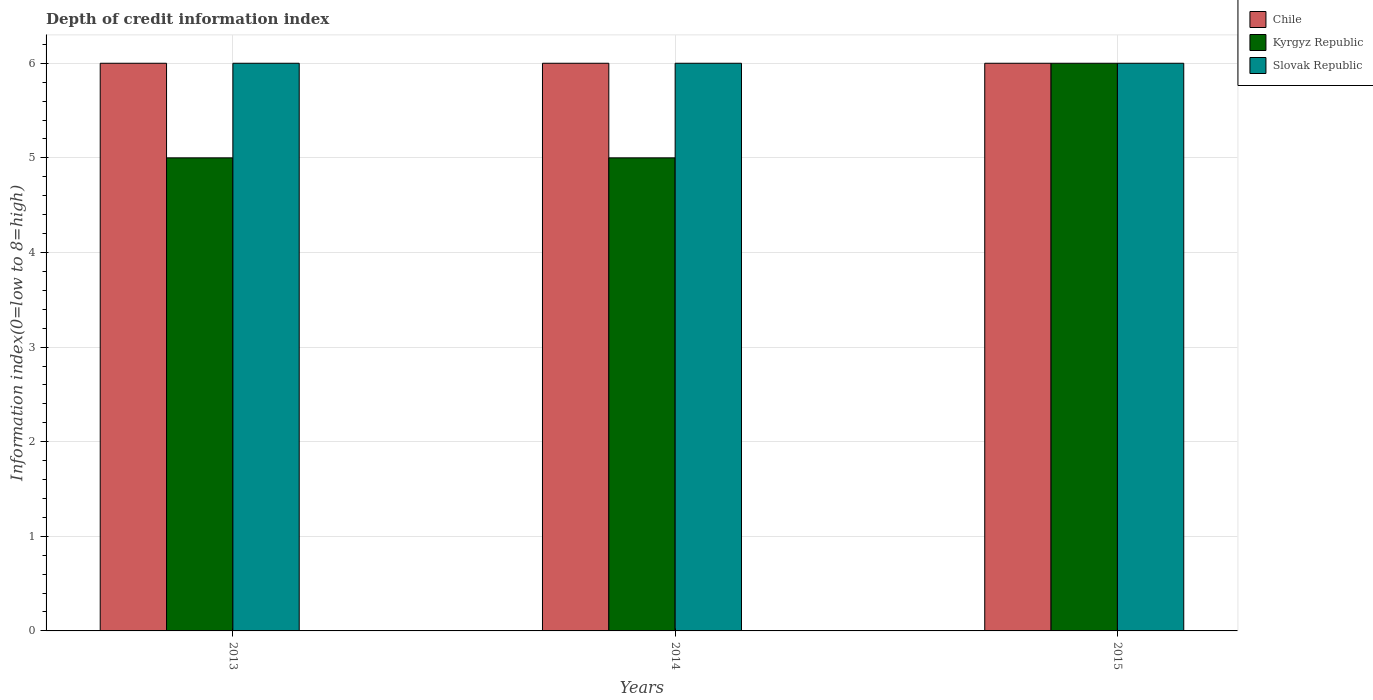How many different coloured bars are there?
Offer a terse response. 3. How many groups of bars are there?
Keep it short and to the point. 3. Are the number of bars per tick equal to the number of legend labels?
Make the answer very short. Yes. Are the number of bars on each tick of the X-axis equal?
Your response must be concise. Yes. How many bars are there on the 1st tick from the left?
Provide a succinct answer. 3. In how many cases, is the number of bars for a given year not equal to the number of legend labels?
Your answer should be very brief. 0. Across all years, what is the maximum information index in Kyrgyz Republic?
Your response must be concise. 6. Across all years, what is the minimum information index in Kyrgyz Republic?
Keep it short and to the point. 5. In which year was the information index in Kyrgyz Republic maximum?
Keep it short and to the point. 2015. What is the total information index in Slovak Republic in the graph?
Your answer should be very brief. 18. What is the difference between the information index in Kyrgyz Republic in 2015 and the information index in Slovak Republic in 2013?
Offer a very short reply. 0. In the year 2013, what is the difference between the information index in Slovak Republic and information index in Chile?
Provide a short and direct response. 0. In how many years, is the information index in Slovak Republic greater than 1.8?
Keep it short and to the point. 3. What is the ratio of the information index in Kyrgyz Republic in 2013 to that in 2014?
Give a very brief answer. 1. In how many years, is the information index in Chile greater than the average information index in Chile taken over all years?
Make the answer very short. 0. What does the 3rd bar from the left in 2015 represents?
Give a very brief answer. Slovak Republic. What does the 1st bar from the right in 2013 represents?
Provide a succinct answer. Slovak Republic. How many bars are there?
Provide a short and direct response. 9. Are all the bars in the graph horizontal?
Provide a short and direct response. No. Does the graph contain any zero values?
Your response must be concise. No. Where does the legend appear in the graph?
Keep it short and to the point. Top right. How many legend labels are there?
Your response must be concise. 3. What is the title of the graph?
Keep it short and to the point. Depth of credit information index. Does "Kazakhstan" appear as one of the legend labels in the graph?
Offer a terse response. No. What is the label or title of the Y-axis?
Provide a succinct answer. Information index(0=low to 8=high). What is the Information index(0=low to 8=high) in Chile in 2014?
Give a very brief answer. 6. What is the Information index(0=low to 8=high) in Kyrgyz Republic in 2014?
Your answer should be compact. 5. What is the Information index(0=low to 8=high) in Slovak Republic in 2014?
Ensure brevity in your answer.  6. What is the Information index(0=low to 8=high) in Chile in 2015?
Your answer should be compact. 6. What is the Information index(0=low to 8=high) in Slovak Republic in 2015?
Provide a succinct answer. 6. Across all years, what is the maximum Information index(0=low to 8=high) in Chile?
Offer a terse response. 6. Across all years, what is the minimum Information index(0=low to 8=high) in Kyrgyz Republic?
Keep it short and to the point. 5. What is the total Information index(0=low to 8=high) in Chile in the graph?
Make the answer very short. 18. What is the total Information index(0=low to 8=high) of Kyrgyz Republic in the graph?
Make the answer very short. 16. What is the total Information index(0=low to 8=high) of Slovak Republic in the graph?
Keep it short and to the point. 18. What is the difference between the Information index(0=low to 8=high) in Chile in 2013 and that in 2014?
Make the answer very short. 0. What is the difference between the Information index(0=low to 8=high) of Kyrgyz Republic in 2013 and that in 2014?
Offer a very short reply. 0. What is the difference between the Information index(0=low to 8=high) of Slovak Republic in 2013 and that in 2015?
Your response must be concise. 0. What is the difference between the Information index(0=low to 8=high) in Chile in 2014 and that in 2015?
Offer a very short reply. 0. What is the difference between the Information index(0=low to 8=high) of Slovak Republic in 2014 and that in 2015?
Keep it short and to the point. 0. What is the difference between the Information index(0=low to 8=high) of Chile in 2013 and the Information index(0=low to 8=high) of Slovak Republic in 2014?
Offer a very short reply. 0. What is the difference between the Information index(0=low to 8=high) of Kyrgyz Republic in 2013 and the Information index(0=low to 8=high) of Slovak Republic in 2015?
Provide a succinct answer. -1. What is the average Information index(0=low to 8=high) in Kyrgyz Republic per year?
Offer a terse response. 5.33. What is the average Information index(0=low to 8=high) of Slovak Republic per year?
Your response must be concise. 6. In the year 2013, what is the difference between the Information index(0=low to 8=high) in Chile and Information index(0=low to 8=high) in Slovak Republic?
Ensure brevity in your answer.  0. In the year 2014, what is the difference between the Information index(0=low to 8=high) of Chile and Information index(0=low to 8=high) of Kyrgyz Republic?
Ensure brevity in your answer.  1. In the year 2014, what is the difference between the Information index(0=low to 8=high) in Chile and Information index(0=low to 8=high) in Slovak Republic?
Give a very brief answer. 0. In the year 2014, what is the difference between the Information index(0=low to 8=high) in Kyrgyz Republic and Information index(0=low to 8=high) in Slovak Republic?
Your answer should be compact. -1. In the year 2015, what is the difference between the Information index(0=low to 8=high) of Chile and Information index(0=low to 8=high) of Slovak Republic?
Make the answer very short. 0. What is the ratio of the Information index(0=low to 8=high) of Kyrgyz Republic in 2013 to that in 2014?
Your answer should be very brief. 1. What is the ratio of the Information index(0=low to 8=high) of Chile in 2013 to that in 2015?
Provide a succinct answer. 1. What is the ratio of the Information index(0=low to 8=high) in Chile in 2014 to that in 2015?
Your response must be concise. 1. What is the ratio of the Information index(0=low to 8=high) in Slovak Republic in 2014 to that in 2015?
Offer a very short reply. 1. What is the difference between the highest and the second highest Information index(0=low to 8=high) of Chile?
Offer a terse response. 0. 